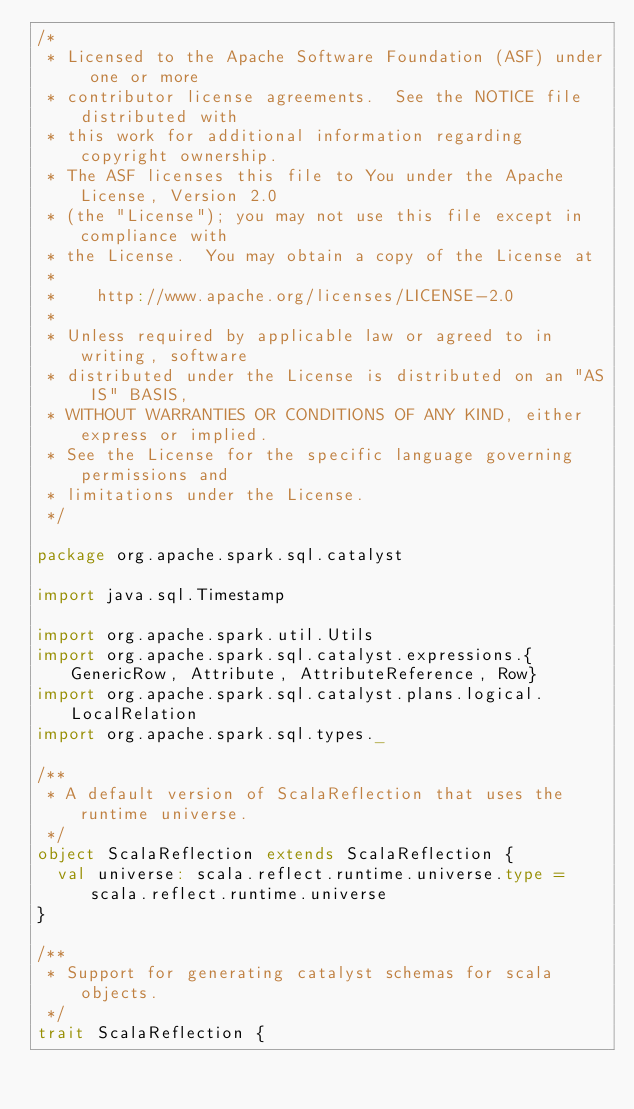<code> <loc_0><loc_0><loc_500><loc_500><_Scala_>/*
 * Licensed to the Apache Software Foundation (ASF) under one or more
 * contributor license agreements.  See the NOTICE file distributed with
 * this work for additional information regarding copyright ownership.
 * The ASF licenses this file to You under the Apache License, Version 2.0
 * (the "License"); you may not use this file except in compliance with
 * the License.  You may obtain a copy of the License at
 *
 *    http://www.apache.org/licenses/LICENSE-2.0
 *
 * Unless required by applicable law or agreed to in writing, software
 * distributed under the License is distributed on an "AS IS" BASIS,
 * WITHOUT WARRANTIES OR CONDITIONS OF ANY KIND, either express or implied.
 * See the License for the specific language governing permissions and
 * limitations under the License.
 */

package org.apache.spark.sql.catalyst

import java.sql.Timestamp

import org.apache.spark.util.Utils
import org.apache.spark.sql.catalyst.expressions.{GenericRow, Attribute, AttributeReference, Row}
import org.apache.spark.sql.catalyst.plans.logical.LocalRelation
import org.apache.spark.sql.types._

/**
 * A default version of ScalaReflection that uses the runtime universe.
 */
object ScalaReflection extends ScalaReflection {
  val universe: scala.reflect.runtime.universe.type = scala.reflect.runtime.universe
}

/**
 * Support for generating catalyst schemas for scala objects.
 */
trait ScalaReflection {</code> 